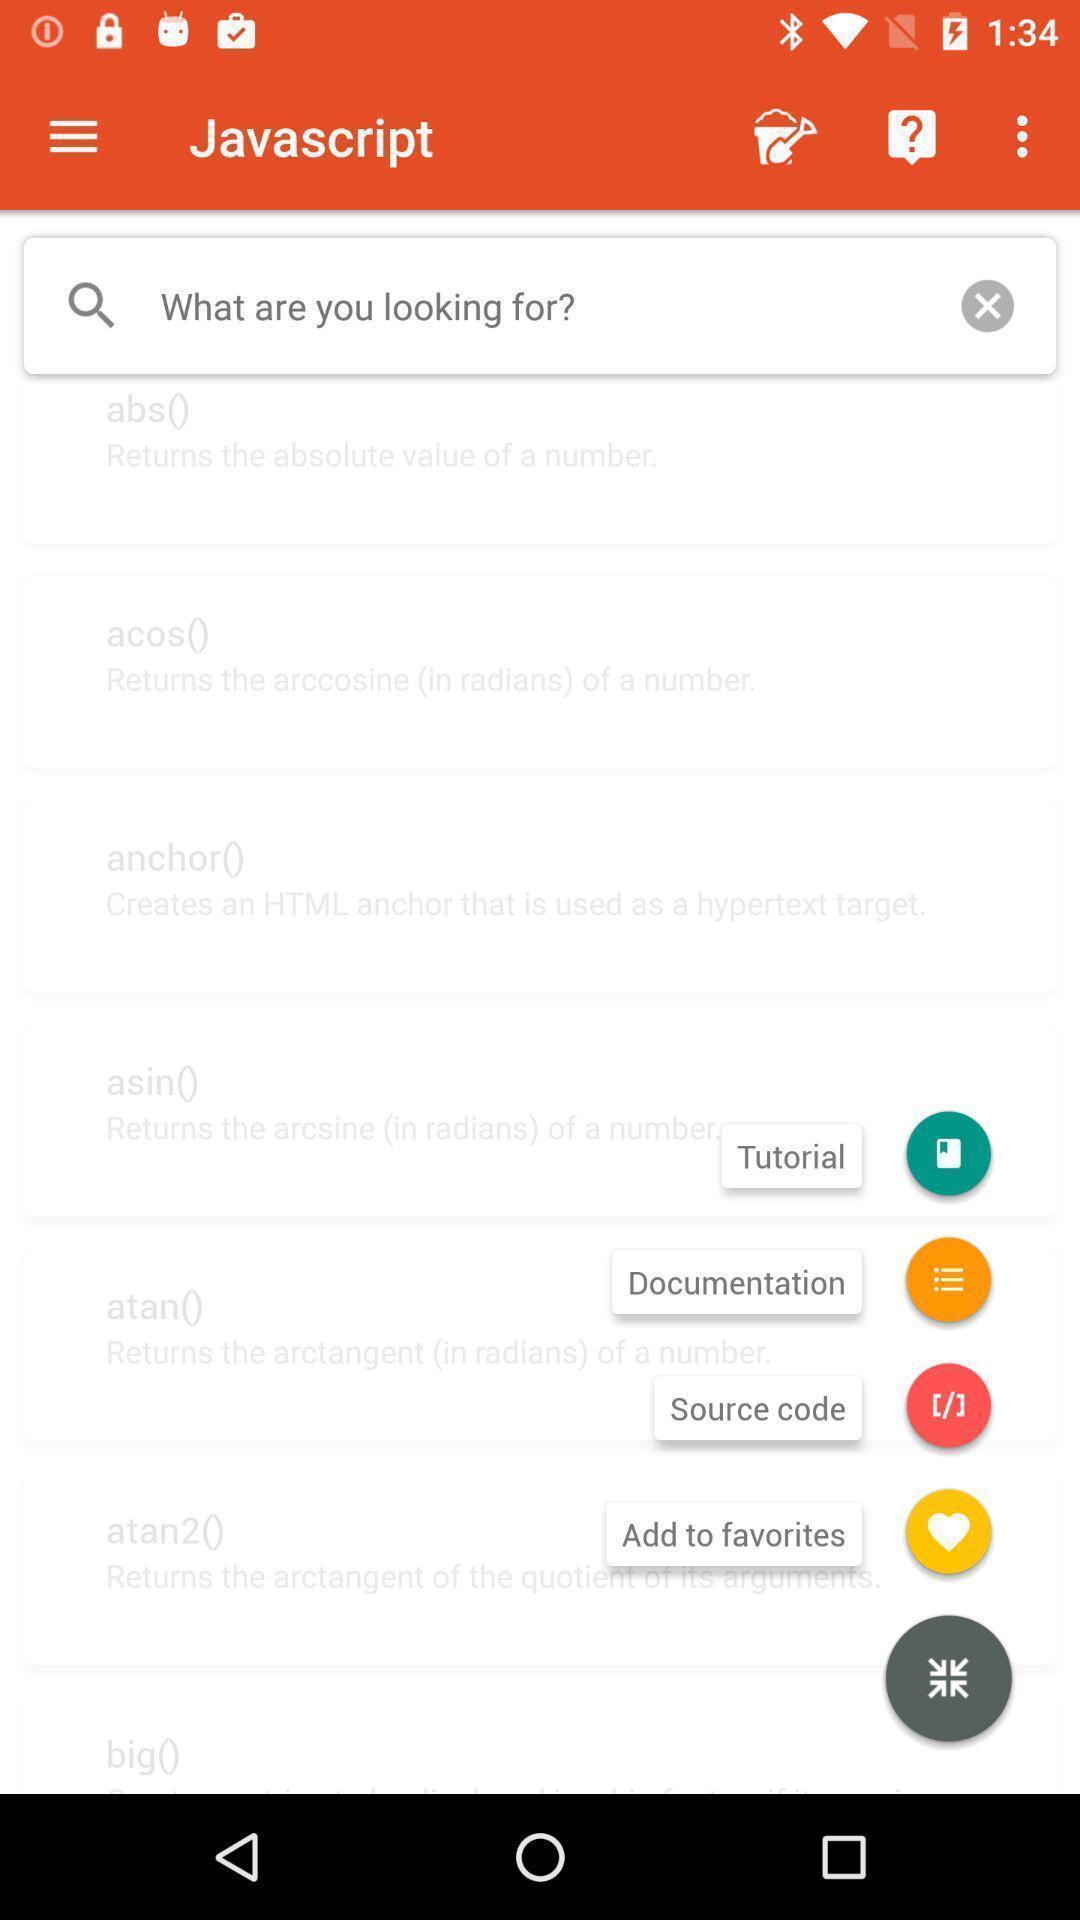Describe this image in words. Screen shows multiple options in a learning application. 